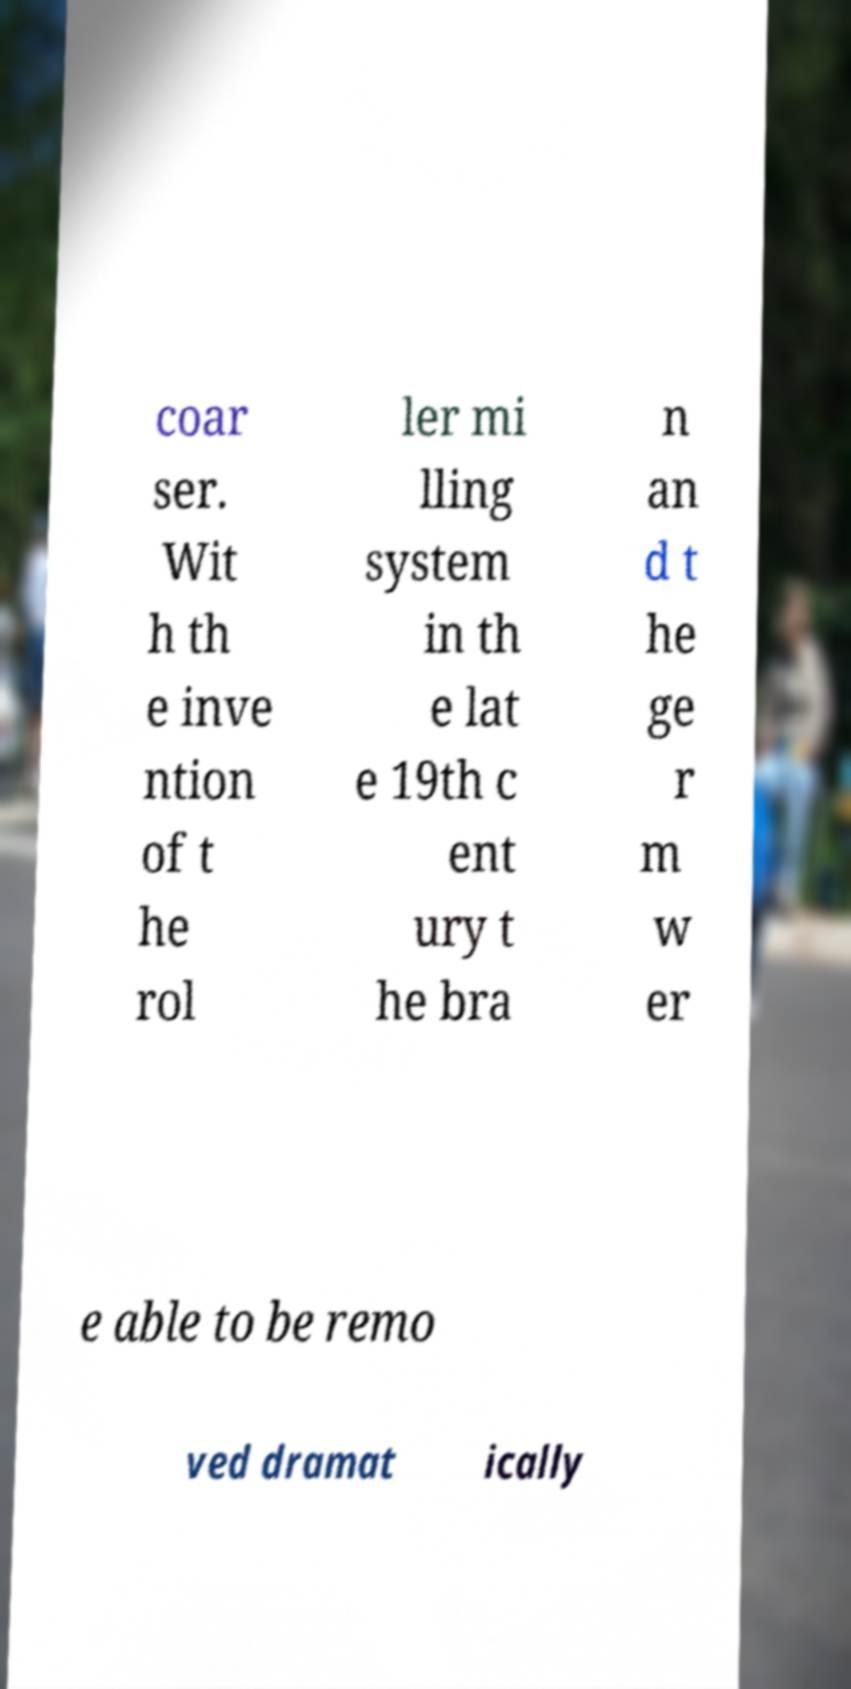There's text embedded in this image that I need extracted. Can you transcribe it verbatim? coar ser. Wit h th e inve ntion of t he rol ler mi lling system in th e lat e 19th c ent ury t he bra n an d t he ge r m w er e able to be remo ved dramat ically 